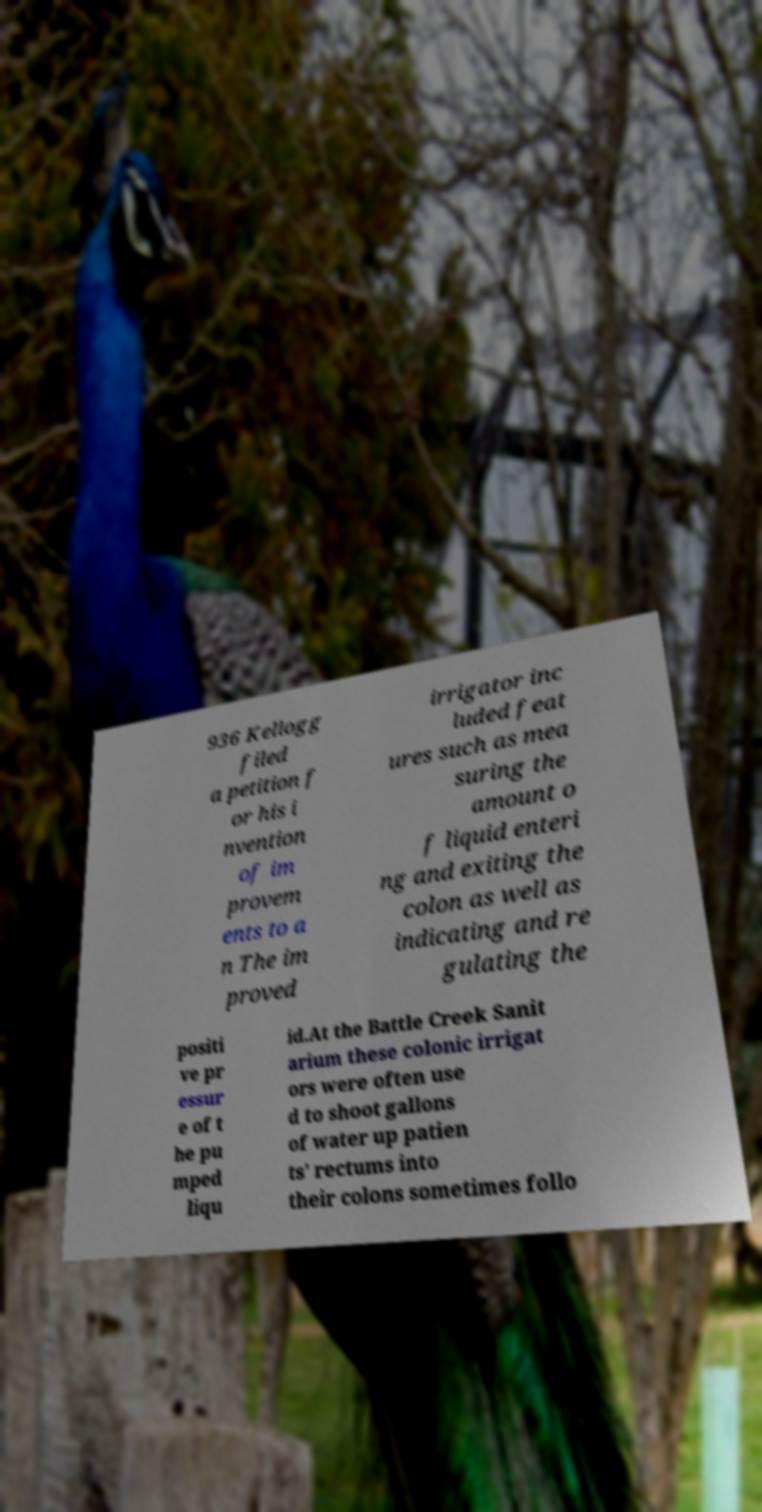Could you assist in decoding the text presented in this image and type it out clearly? 936 Kellogg filed a petition f or his i nvention of im provem ents to a n The im proved irrigator inc luded feat ures such as mea suring the amount o f liquid enteri ng and exiting the colon as well as indicating and re gulating the positi ve pr essur e of t he pu mped liqu id.At the Battle Creek Sanit arium these colonic irrigat ors were often use d to shoot gallons of water up patien ts' rectums into their colons sometimes follo 